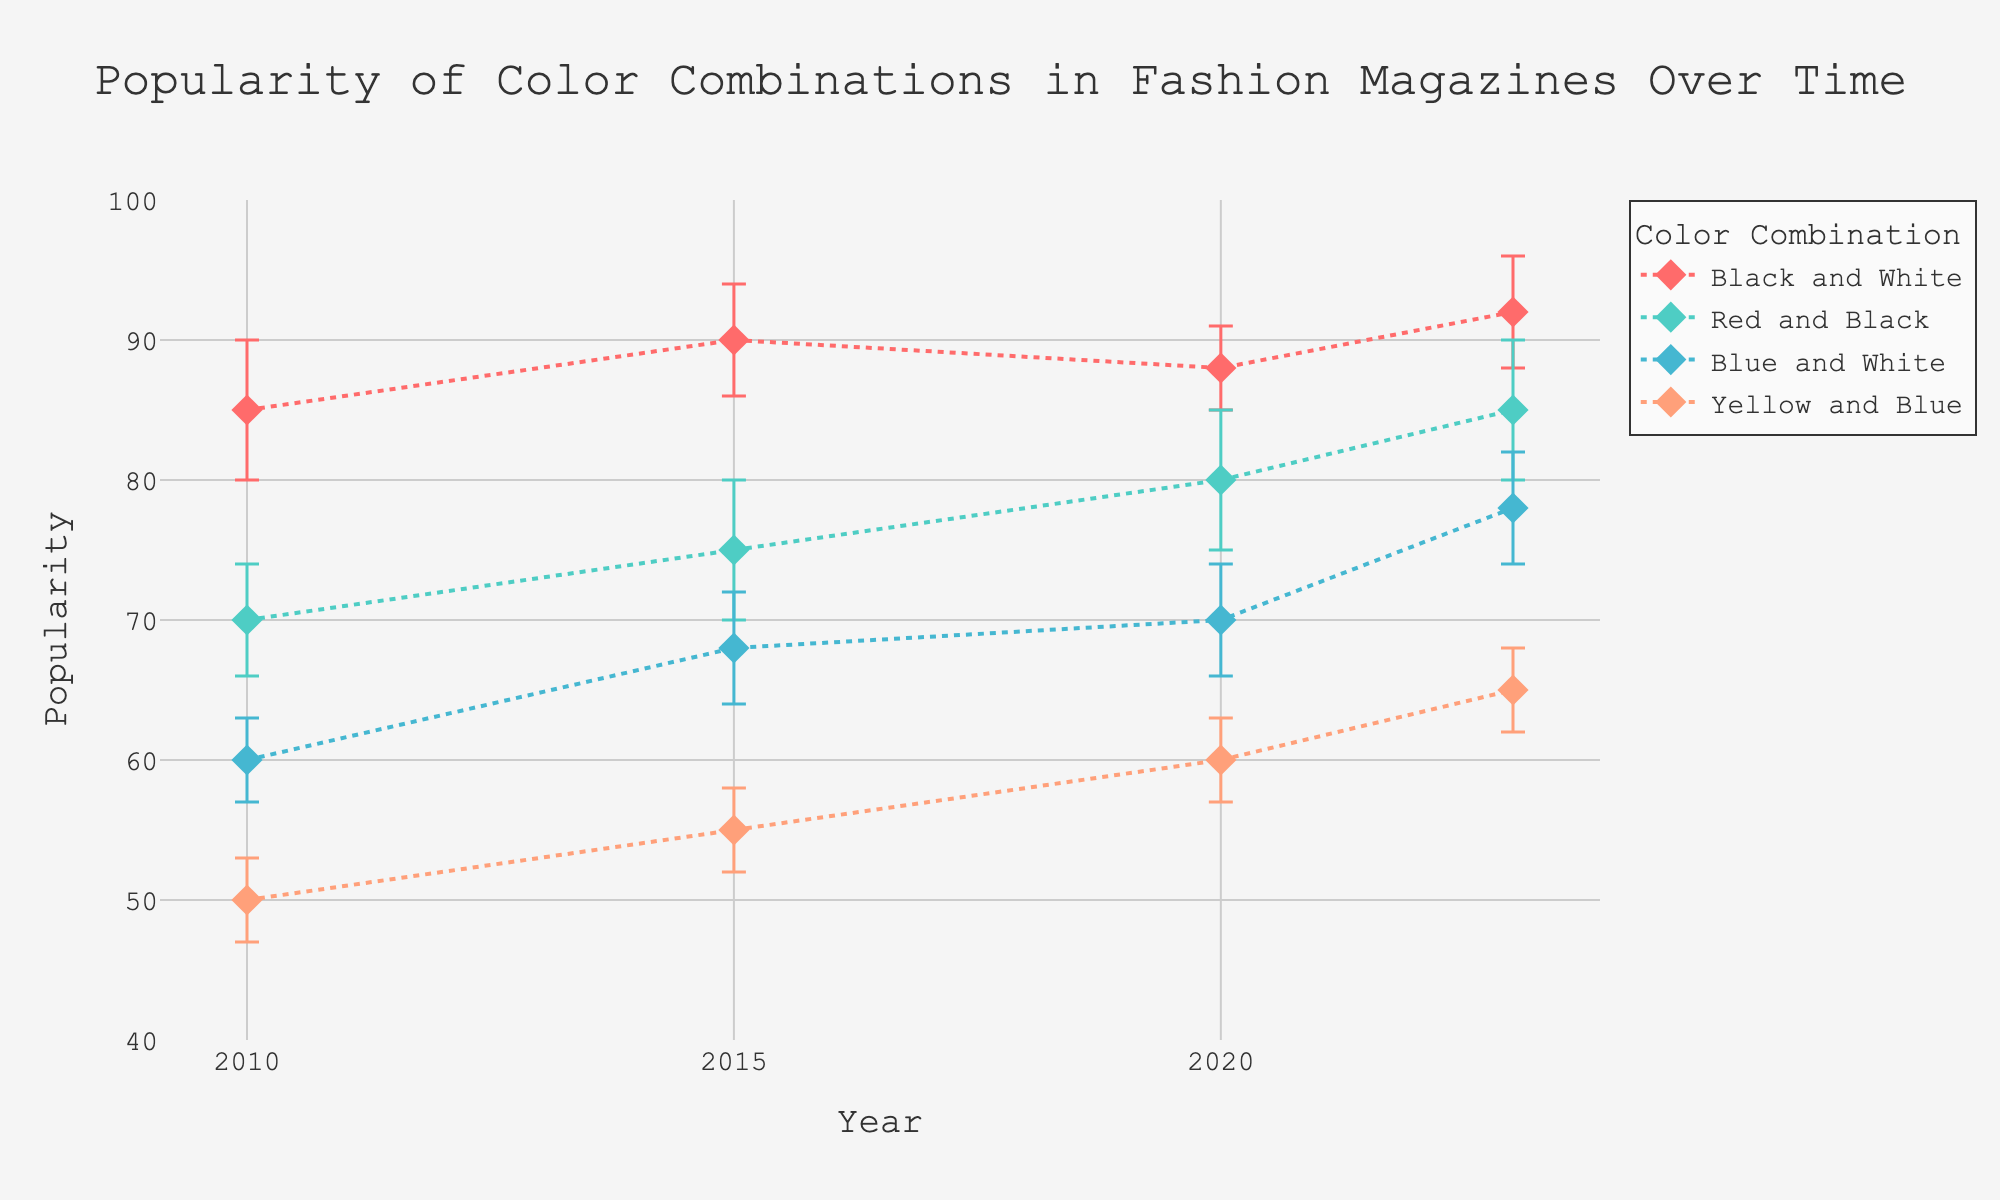What is the title of the figure? The title is usually displayed at the top of the figure. In this case, it is clear and easy to read.
Answer: Popularity of Color Combinations in Fashion Magazines Over Time Which year has the highest popularity for the "Red and Black" color combination? The year with the highest popularity for "Red and Black" will have the highest dot for this combination. In the figure, you can identify the highest dot for "Red and Black" and its corresponding year.
Answer: 2023 How does the popularity of "Black and White" change from 2010 to 2023? To determine this, observe the trend line for "Black and White." Identify the dots in 2010 and 2023 and note their popularity values. Compare these values to understand the change.
Answer: It increases from 85 to 92 What is the average popularity of the "Blue and White" color combination over the years? Calculate the average by summing the popularity values for "Blue and White" across the years (60, 68, 70, 78) and then dividing by the number of data points (4).
Answer: (60 + 68 + 70 + 78) / 4 = 69 Which color combination consistently shows an increase in popularity over the years? Identify the combinations that show an upward trend across all years without any decline. Look at each line and see which one never goes down.
Answer: Black and White How do the error margins for "Yellow and Blue" change over the years? Examine the error bars associated with "Yellow and Blue" in each year. Note their sizes to see if they increase, decrease, or remain consistent.
Answer: They remain consistent at 3 Which year has the highest overall popularity across all color combinations? Sum the popularity values for all combinations in each year. Compare the totals to see which year has the highest sum.
Answer: 2023 Are there any color combinations that have a declining popularity trend from 2015 to 2020? Look at each color combination's line from 2015 to 2020 and see if there is a downward slope.
Answer: No Between "Blue and White" and "Yellow and Blue," which had the greater popularity increase from 2010 to 2020? Calculate the increase for both combinations by subtracting the 2020 value from the 2010 value. Compare the results to see which is higher.
Answer: Blue and White (10 vs 10) 